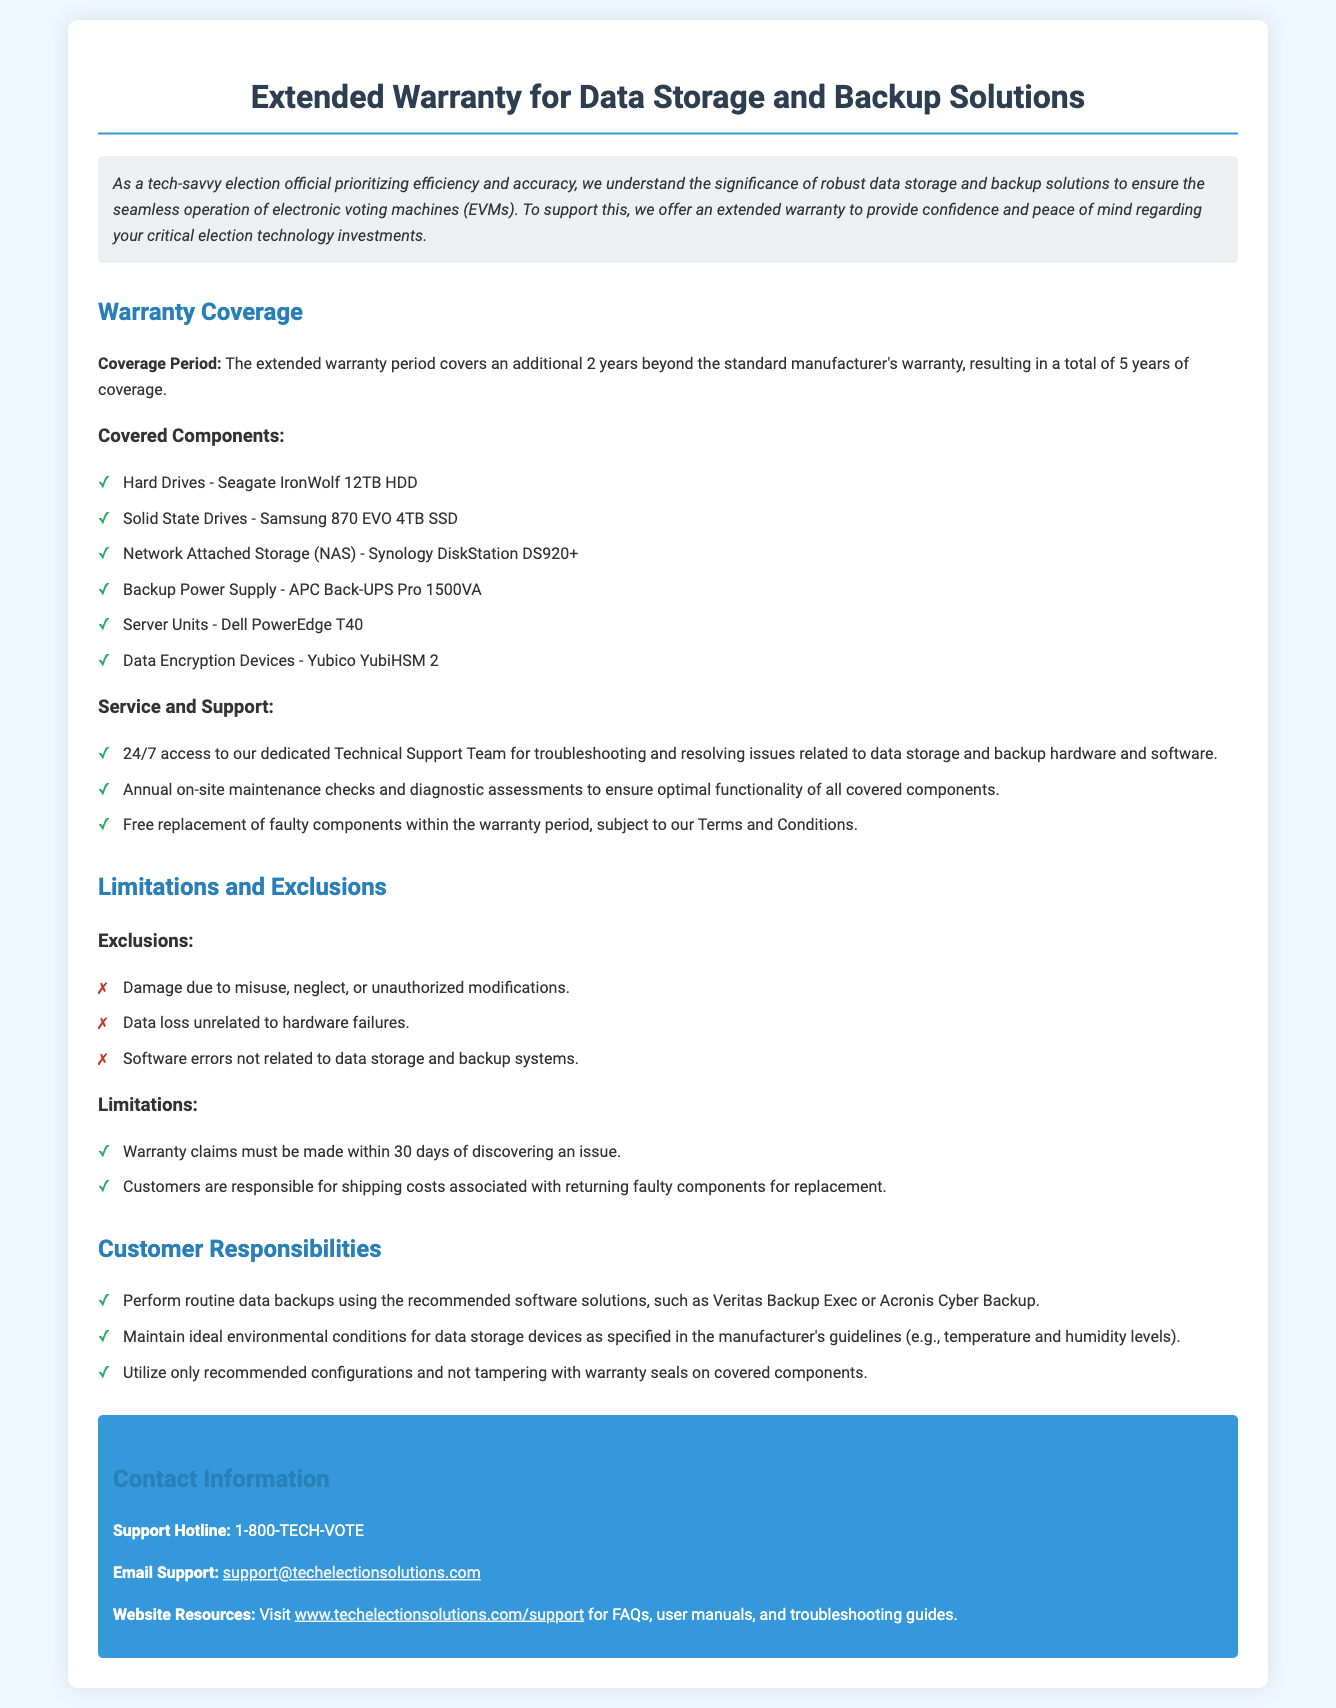What is the coverage period of the extended warranty? The document states that the extended warranty period covers an additional 2 years beyond the standard manufacturer's warranty, resulting in a total of 5 years of coverage.
Answer: 5 years What type of Hard Drive is covered under the warranty? The specific Hard Drive covered is the Seagate IronWolf 12TB HDD mentioned in the document.
Answer: Seagate IronWolf 12TB HDD What service is provided 24/7? The document mentions that 24/7 access is available to the dedicated Technical Support Team for troubleshooting and resolving issues.
Answer: Technical Support What exclusions relate to data loss? The document specifies that data loss unrelated to hardware failures is an exclusion with no warranty coverage.
Answer: Data loss unrelated to hardware failures What must customers do regarding warranty claims? According to the document, warranty claims must be made within 30 days of discovering an issue.
Answer: 30 days How often are maintenance checks performed? The document indicates that annual on-site maintenance checks are conducted.
Answer: Annual What device is specified for backup power supply? The document identifies the APC Back-UPS Pro 1500VA as the backup power supply covered under the warranty.
Answer: APC Back-UPS Pro 1500VA What is one customer responsibility mentioned? The document states that customers are responsible for performing routine data backups using recommended software solutions.
Answer: Routine data backups 